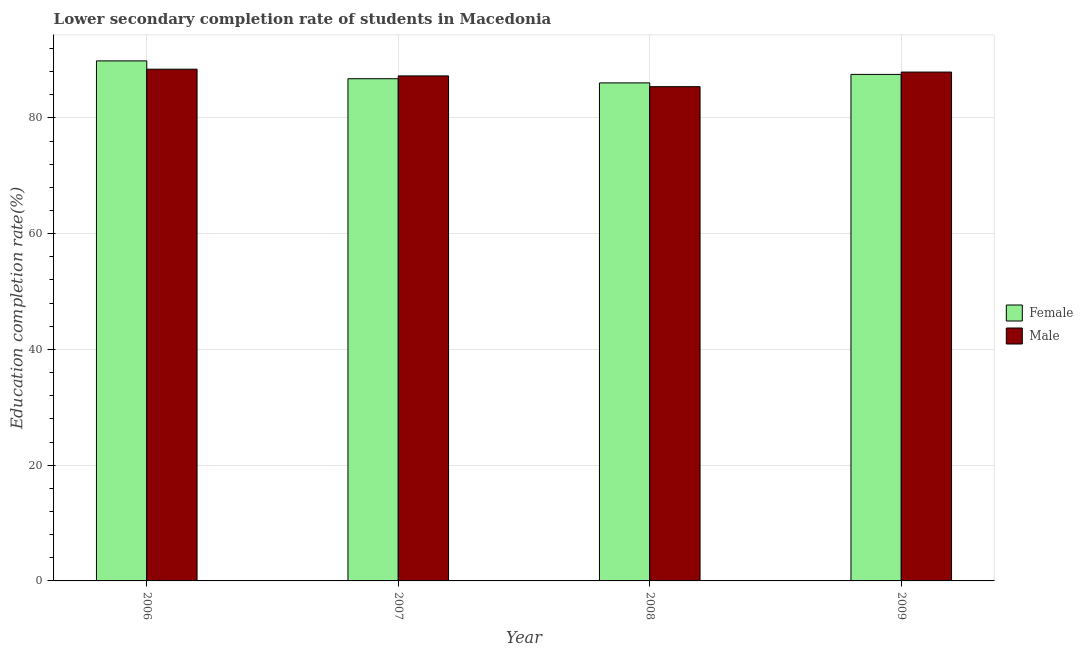How many groups of bars are there?
Provide a succinct answer. 4. Are the number of bars on each tick of the X-axis equal?
Your answer should be compact. Yes. How many bars are there on the 2nd tick from the left?
Your response must be concise. 2. How many bars are there on the 3rd tick from the right?
Keep it short and to the point. 2. In how many cases, is the number of bars for a given year not equal to the number of legend labels?
Make the answer very short. 0. What is the education completion rate of female students in 2007?
Your answer should be compact. 86.76. Across all years, what is the maximum education completion rate of female students?
Ensure brevity in your answer.  89.84. Across all years, what is the minimum education completion rate of male students?
Your answer should be very brief. 85.39. In which year was the education completion rate of female students maximum?
Your answer should be compact. 2006. In which year was the education completion rate of female students minimum?
Offer a very short reply. 2008. What is the total education completion rate of male students in the graph?
Provide a succinct answer. 348.95. What is the difference between the education completion rate of female students in 2007 and that in 2009?
Offer a very short reply. -0.75. What is the difference between the education completion rate of male students in 2008 and the education completion rate of female students in 2006?
Make the answer very short. -3.02. What is the average education completion rate of male students per year?
Your response must be concise. 87.24. What is the ratio of the education completion rate of male students in 2008 to that in 2009?
Provide a short and direct response. 0.97. Is the difference between the education completion rate of male students in 2007 and 2008 greater than the difference between the education completion rate of female students in 2007 and 2008?
Offer a terse response. No. What is the difference between the highest and the second highest education completion rate of male students?
Give a very brief answer. 0.5. What is the difference between the highest and the lowest education completion rate of male students?
Offer a terse response. 3.02. In how many years, is the education completion rate of male students greater than the average education completion rate of male students taken over all years?
Your answer should be compact. 3. Is the sum of the education completion rate of male students in 2006 and 2008 greater than the maximum education completion rate of female students across all years?
Offer a very short reply. Yes. What is the difference between two consecutive major ticks on the Y-axis?
Your response must be concise. 20. Are the values on the major ticks of Y-axis written in scientific E-notation?
Your answer should be compact. No. Does the graph contain any zero values?
Make the answer very short. No. Does the graph contain grids?
Give a very brief answer. Yes. Where does the legend appear in the graph?
Offer a terse response. Center right. How many legend labels are there?
Offer a very short reply. 2. What is the title of the graph?
Make the answer very short. Lower secondary completion rate of students in Macedonia. What is the label or title of the Y-axis?
Provide a succinct answer. Education completion rate(%). What is the Education completion rate(%) in Female in 2006?
Your answer should be compact. 89.84. What is the Education completion rate(%) of Male in 2006?
Give a very brief answer. 88.41. What is the Education completion rate(%) of Female in 2007?
Your response must be concise. 86.76. What is the Education completion rate(%) in Male in 2007?
Your answer should be compact. 87.25. What is the Education completion rate(%) of Female in 2008?
Offer a terse response. 86.04. What is the Education completion rate(%) of Male in 2008?
Give a very brief answer. 85.39. What is the Education completion rate(%) in Female in 2009?
Offer a very short reply. 87.51. What is the Education completion rate(%) of Male in 2009?
Offer a terse response. 87.91. Across all years, what is the maximum Education completion rate(%) in Female?
Offer a terse response. 89.84. Across all years, what is the maximum Education completion rate(%) of Male?
Ensure brevity in your answer.  88.41. Across all years, what is the minimum Education completion rate(%) of Female?
Give a very brief answer. 86.04. Across all years, what is the minimum Education completion rate(%) in Male?
Offer a terse response. 85.39. What is the total Education completion rate(%) in Female in the graph?
Offer a very short reply. 350.15. What is the total Education completion rate(%) of Male in the graph?
Your response must be concise. 348.95. What is the difference between the Education completion rate(%) in Female in 2006 and that in 2007?
Provide a short and direct response. 3.08. What is the difference between the Education completion rate(%) of Male in 2006 and that in 2007?
Keep it short and to the point. 1.16. What is the difference between the Education completion rate(%) in Female in 2006 and that in 2008?
Keep it short and to the point. 3.8. What is the difference between the Education completion rate(%) of Male in 2006 and that in 2008?
Your answer should be very brief. 3.02. What is the difference between the Education completion rate(%) in Female in 2006 and that in 2009?
Give a very brief answer. 2.34. What is the difference between the Education completion rate(%) in Male in 2006 and that in 2009?
Offer a terse response. 0.5. What is the difference between the Education completion rate(%) of Female in 2007 and that in 2008?
Provide a short and direct response. 0.72. What is the difference between the Education completion rate(%) of Male in 2007 and that in 2008?
Provide a succinct answer. 1.86. What is the difference between the Education completion rate(%) of Female in 2007 and that in 2009?
Your response must be concise. -0.75. What is the difference between the Education completion rate(%) of Male in 2007 and that in 2009?
Ensure brevity in your answer.  -0.66. What is the difference between the Education completion rate(%) of Female in 2008 and that in 2009?
Offer a very short reply. -1.47. What is the difference between the Education completion rate(%) in Male in 2008 and that in 2009?
Provide a succinct answer. -2.52. What is the difference between the Education completion rate(%) of Female in 2006 and the Education completion rate(%) of Male in 2007?
Provide a succinct answer. 2.59. What is the difference between the Education completion rate(%) in Female in 2006 and the Education completion rate(%) in Male in 2008?
Offer a very short reply. 4.46. What is the difference between the Education completion rate(%) in Female in 2006 and the Education completion rate(%) in Male in 2009?
Ensure brevity in your answer.  1.93. What is the difference between the Education completion rate(%) of Female in 2007 and the Education completion rate(%) of Male in 2008?
Your answer should be compact. 1.37. What is the difference between the Education completion rate(%) in Female in 2007 and the Education completion rate(%) in Male in 2009?
Your answer should be compact. -1.15. What is the difference between the Education completion rate(%) in Female in 2008 and the Education completion rate(%) in Male in 2009?
Provide a succinct answer. -1.87. What is the average Education completion rate(%) in Female per year?
Your response must be concise. 87.54. What is the average Education completion rate(%) in Male per year?
Your answer should be compact. 87.24. In the year 2006, what is the difference between the Education completion rate(%) of Female and Education completion rate(%) of Male?
Ensure brevity in your answer.  1.44. In the year 2007, what is the difference between the Education completion rate(%) in Female and Education completion rate(%) in Male?
Your answer should be compact. -0.49. In the year 2008, what is the difference between the Education completion rate(%) in Female and Education completion rate(%) in Male?
Ensure brevity in your answer.  0.65. In the year 2009, what is the difference between the Education completion rate(%) in Female and Education completion rate(%) in Male?
Make the answer very short. -0.4. What is the ratio of the Education completion rate(%) of Female in 2006 to that in 2007?
Ensure brevity in your answer.  1.04. What is the ratio of the Education completion rate(%) in Male in 2006 to that in 2007?
Keep it short and to the point. 1.01. What is the ratio of the Education completion rate(%) of Female in 2006 to that in 2008?
Offer a very short reply. 1.04. What is the ratio of the Education completion rate(%) in Male in 2006 to that in 2008?
Offer a terse response. 1.04. What is the ratio of the Education completion rate(%) of Female in 2006 to that in 2009?
Your answer should be compact. 1.03. What is the ratio of the Education completion rate(%) of Male in 2006 to that in 2009?
Offer a terse response. 1.01. What is the ratio of the Education completion rate(%) of Female in 2007 to that in 2008?
Make the answer very short. 1.01. What is the ratio of the Education completion rate(%) in Male in 2007 to that in 2008?
Provide a short and direct response. 1.02. What is the ratio of the Education completion rate(%) in Female in 2007 to that in 2009?
Offer a terse response. 0.99. What is the ratio of the Education completion rate(%) of Female in 2008 to that in 2009?
Keep it short and to the point. 0.98. What is the ratio of the Education completion rate(%) of Male in 2008 to that in 2009?
Your response must be concise. 0.97. What is the difference between the highest and the second highest Education completion rate(%) of Female?
Keep it short and to the point. 2.34. What is the difference between the highest and the second highest Education completion rate(%) of Male?
Offer a very short reply. 0.5. What is the difference between the highest and the lowest Education completion rate(%) of Female?
Ensure brevity in your answer.  3.8. What is the difference between the highest and the lowest Education completion rate(%) in Male?
Give a very brief answer. 3.02. 